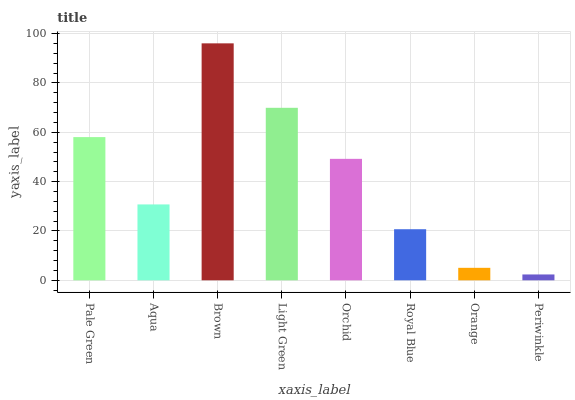Is Periwinkle the minimum?
Answer yes or no. Yes. Is Brown the maximum?
Answer yes or no. Yes. Is Aqua the minimum?
Answer yes or no. No. Is Aqua the maximum?
Answer yes or no. No. Is Pale Green greater than Aqua?
Answer yes or no. Yes. Is Aqua less than Pale Green?
Answer yes or no. Yes. Is Aqua greater than Pale Green?
Answer yes or no. No. Is Pale Green less than Aqua?
Answer yes or no. No. Is Orchid the high median?
Answer yes or no. Yes. Is Aqua the low median?
Answer yes or no. Yes. Is Aqua the high median?
Answer yes or no. No. Is Brown the low median?
Answer yes or no. No. 